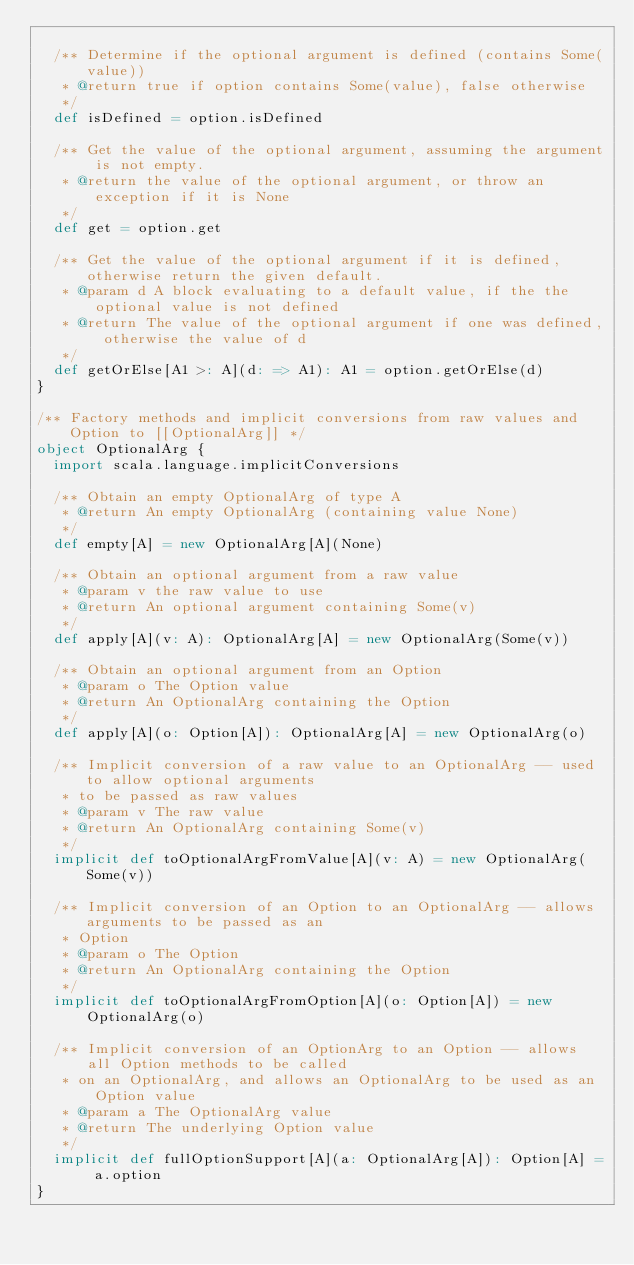Convert code to text. <code><loc_0><loc_0><loc_500><loc_500><_Scala_>
  /** Determine if the optional argument is defined (contains Some(value))
   * @return true if option contains Some(value), false otherwise
   */
  def isDefined = option.isDefined

  /** Get the value of the optional argument, assuming the argument is not empty.
   * @return the value of the optional argument, or throw an exception if it is None
   */
  def get = option.get

  /** Get the value of the optional argument if it is defined, otherwise return the given default.
   * @param d A block evaluating to a default value, if the the optional value is not defined
   * @return The value of the optional argument if one was defined, otherwise the value of d
   */
  def getOrElse[A1 >: A](d: => A1): A1 = option.getOrElse(d)
}

/** Factory methods and implicit conversions from raw values and Option to [[OptionalArg]] */
object OptionalArg {
  import scala.language.implicitConversions

  /** Obtain an empty OptionalArg of type A
   * @return An empty OptionalArg (containing value None)
   */
  def empty[A] = new OptionalArg[A](None)

  /** Obtain an optional argument from a raw value
   * @param v the raw value to use
   * @return An optional argument containing Some(v)
   */
  def apply[A](v: A): OptionalArg[A] = new OptionalArg(Some(v))

  /** Obtain an optional argument from an Option
   * @param o The Option value
   * @return An OptionalArg containing the Option
   */
  def apply[A](o: Option[A]): OptionalArg[A] = new OptionalArg(o)

  /** Implicit conversion of a raw value to an OptionalArg -- used to allow optional arguments 
   * to be passed as raw values
   * @param v The raw value
   * @return An OptionalArg containing Some(v)
   */
  implicit def toOptionalArgFromValue[A](v: A) = new OptionalArg(Some(v))

  /** Implicit conversion of an Option to an OptionalArg -- allows arguments to be passed as an 
   * Option
   * @param o The Option
   * @return An OptionalArg containing the Option
   */
  implicit def toOptionalArgFromOption[A](o: Option[A]) = new OptionalArg(o)

  /** Implicit conversion of an OptionArg to an Option -- allows all Option methods to be called
   * on an OptionalArg, and allows an OptionalArg to be used as an Option value
   * @param a The OptionalArg value
   * @return The underlying Option value
   */ 
  implicit def fullOptionSupport[A](a: OptionalArg[A]): Option[A] = a.option
}
</code> 